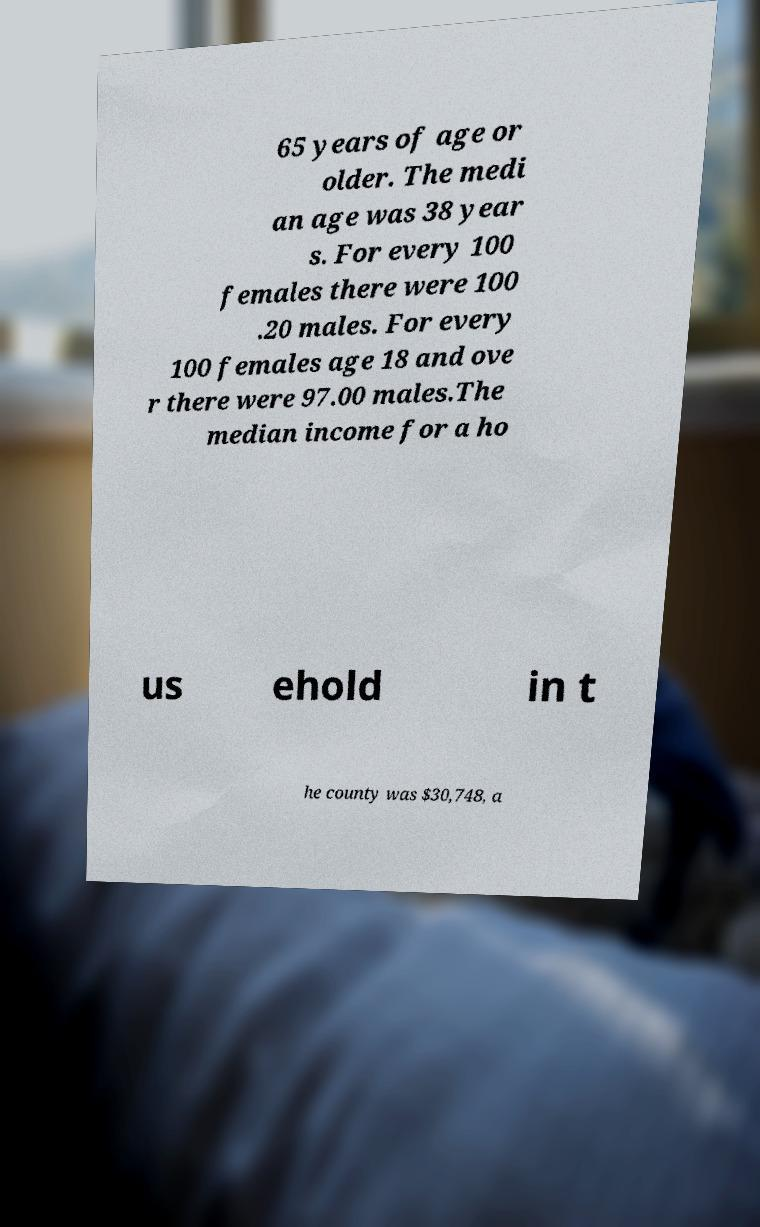For documentation purposes, I need the text within this image transcribed. Could you provide that? 65 years of age or older. The medi an age was 38 year s. For every 100 females there were 100 .20 males. For every 100 females age 18 and ove r there were 97.00 males.The median income for a ho us ehold in t he county was $30,748, a 